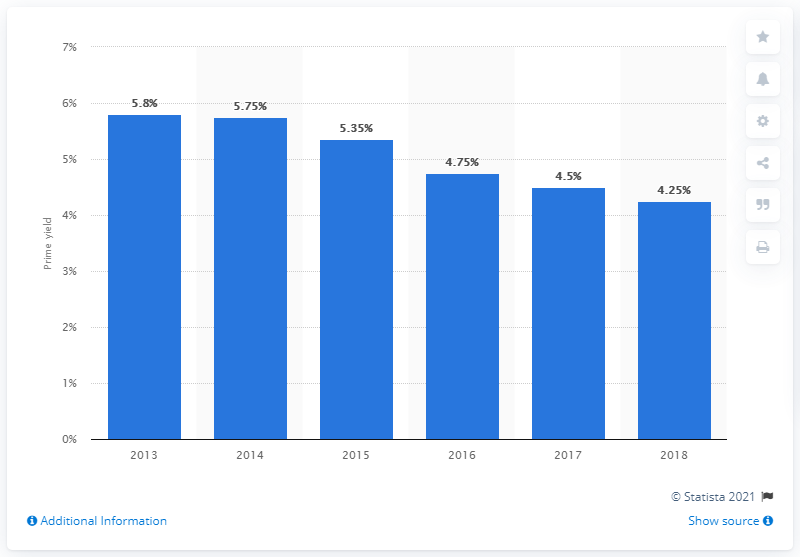Highlight a few significant elements in this photo. According to the information available up to 2018, the prime yield value was 4.25%. According to the information provided, the average office prime yield in Brussels at the end of 2018 was 4.25%. The average of all the blue bars is 5.06. 